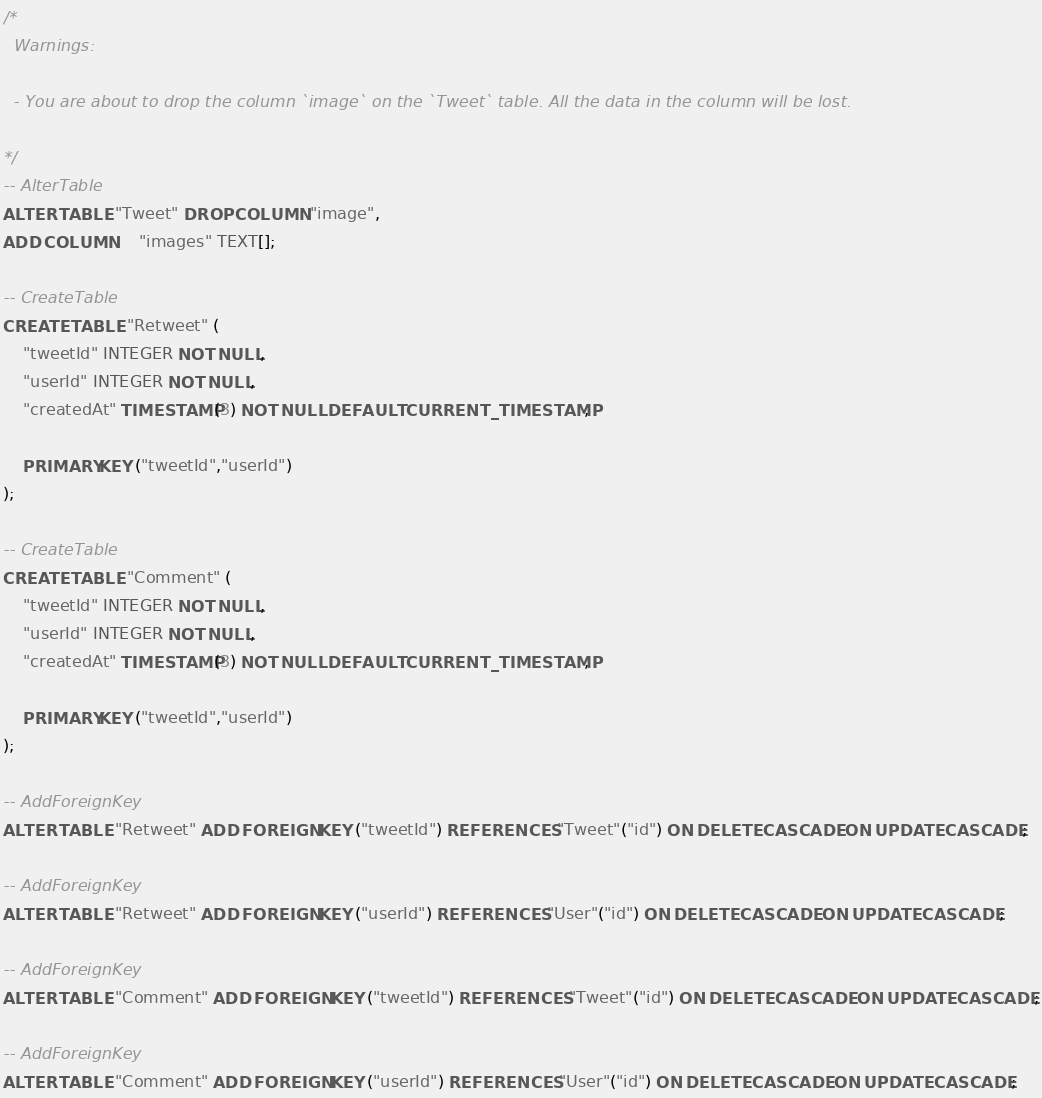Convert code to text. <code><loc_0><loc_0><loc_500><loc_500><_SQL_>/*
  Warnings:

  - You are about to drop the column `image` on the `Tweet` table. All the data in the column will be lost.

*/
-- AlterTable
ALTER TABLE "Tweet" DROP COLUMN "image",
ADD COLUMN     "images" TEXT[];

-- CreateTable
CREATE TABLE "Retweet" (
    "tweetId" INTEGER NOT NULL,
    "userId" INTEGER NOT NULL,
    "createdAt" TIMESTAMP(3) NOT NULL DEFAULT CURRENT_TIMESTAMP,

    PRIMARY KEY ("tweetId","userId")
);

-- CreateTable
CREATE TABLE "Comment" (
    "tweetId" INTEGER NOT NULL,
    "userId" INTEGER NOT NULL,
    "createdAt" TIMESTAMP(3) NOT NULL DEFAULT CURRENT_TIMESTAMP,

    PRIMARY KEY ("tweetId","userId")
);

-- AddForeignKey
ALTER TABLE "Retweet" ADD FOREIGN KEY ("tweetId") REFERENCES "Tweet"("id") ON DELETE CASCADE ON UPDATE CASCADE;

-- AddForeignKey
ALTER TABLE "Retweet" ADD FOREIGN KEY ("userId") REFERENCES "User"("id") ON DELETE CASCADE ON UPDATE CASCADE;

-- AddForeignKey
ALTER TABLE "Comment" ADD FOREIGN KEY ("tweetId") REFERENCES "Tweet"("id") ON DELETE CASCADE ON UPDATE CASCADE;

-- AddForeignKey
ALTER TABLE "Comment" ADD FOREIGN KEY ("userId") REFERENCES "User"("id") ON DELETE CASCADE ON UPDATE CASCADE;
</code> 